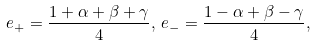Convert formula to latex. <formula><loc_0><loc_0><loc_500><loc_500>e _ { + } = \frac { 1 + \alpha + \beta + \gamma } { 4 } , \, e _ { - } = \frac { 1 - \alpha + \beta - \gamma } { 4 } ,</formula> 